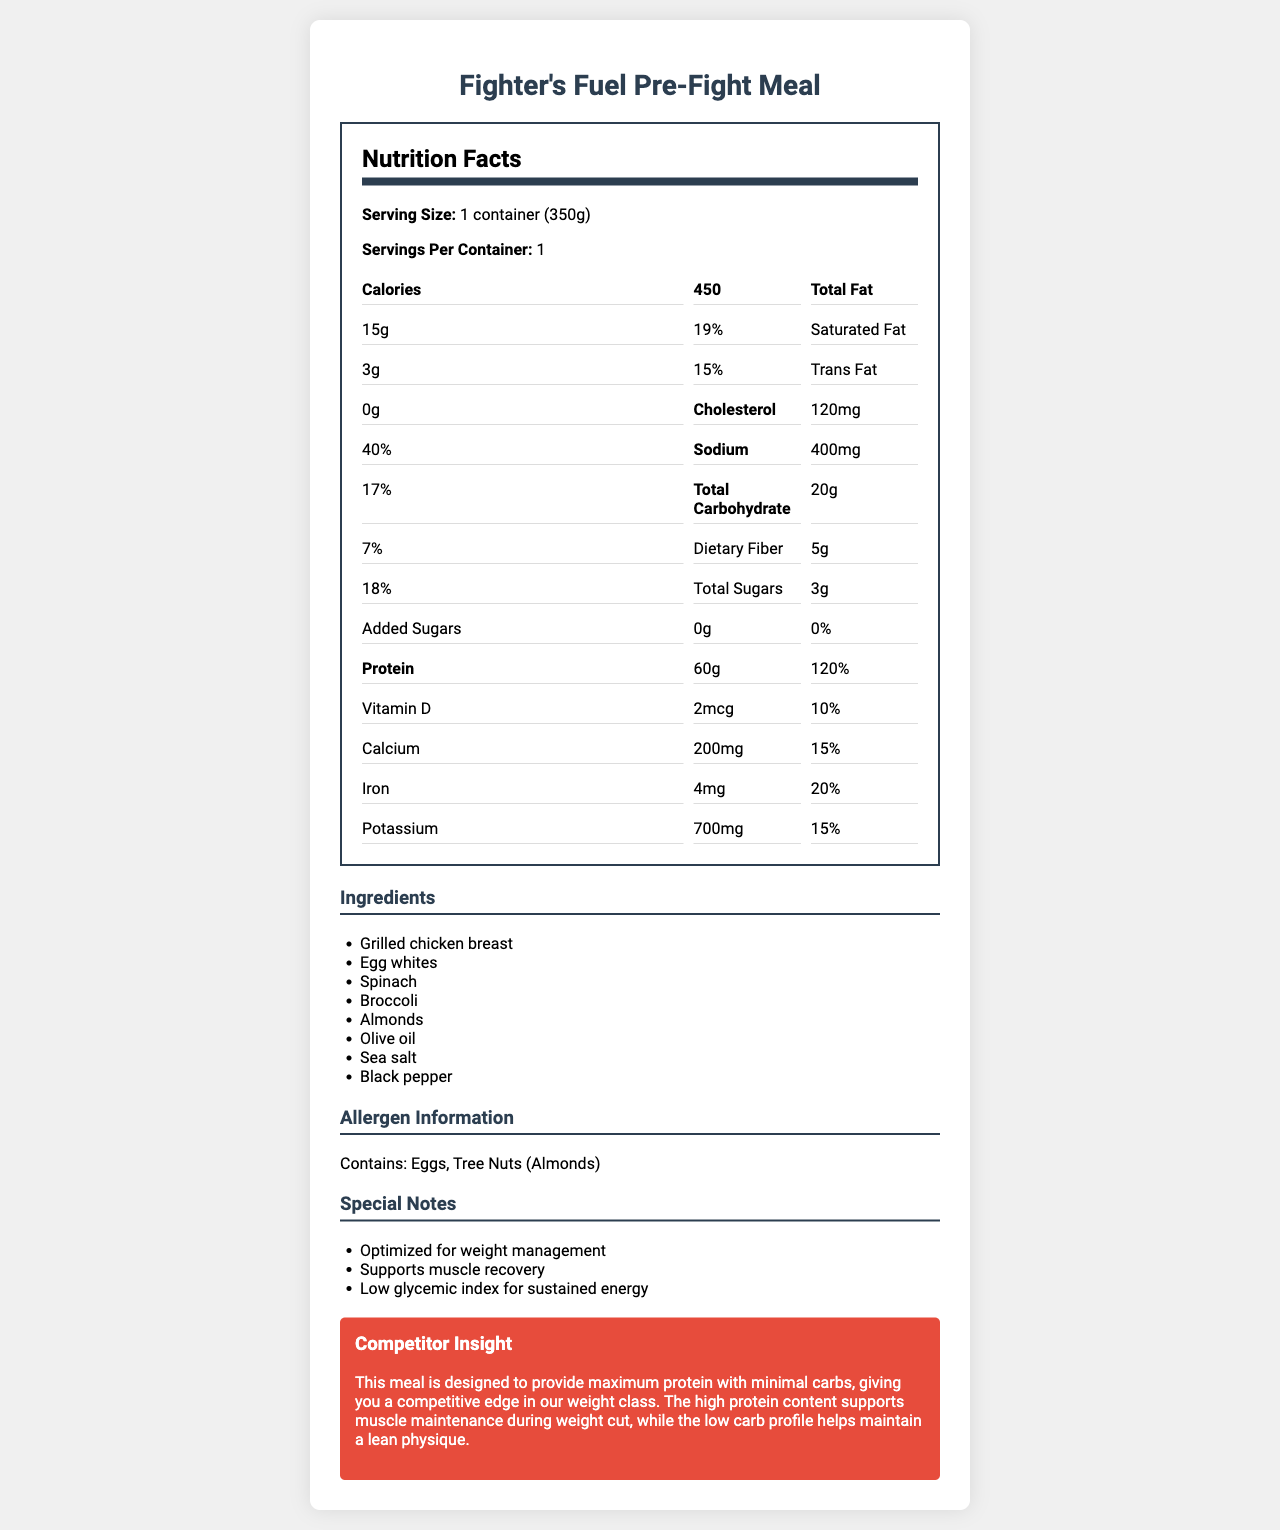what is the serving size of the Fighter's Fuel Pre-Fight Meal? The serving size is stated as "1 container (350g)" in the document.
Answer: 1 container (350g) how many calories are in one serving of the Fighter's Fuel Pre-Fight Meal? The document states that one serving has 450 calories.
Answer: 450 what is the total amount of protein in the Fighter's Fuel Pre-Fight Meal? The document shows that the total protein amount is 60g.
Answer: 60g how much sodium does one serving of Fighter's Fuel Pre-Fight Meal contain? The sodium content per serving is listed as 400mg in the document.
Answer: 400mg which two ingredients in the Fighter's Fuel Pre-Fight Meal are allergens? The allergen information section notes that the meal contains eggs and tree nuts (almonds).
Answer: Eggs, Tree Nuts (Almonds) what is the daily value percentage of calcium in the Fighter's Fuel Pre-Fight Meal? A. 10% B. 15% C. 20% D. 25% The document states that the daily value percentage for calcium is 15%.
Answer: B. 15% which ingredient is not part of the Fighter's Fuel Pre-Fight Meal? I. Grilled chicken breast II. Spinach III. Broccoli IV. Tomatoes The list of ingredients does not include tomatoes.
Answer: IV. Tomatoes is the Fighter's Fuel Pre-Fight Meal considered high in dietary fiber? (yes/no) The meal contains 5g of dietary fiber, which is 18% of the daily value, suggesting it is relatively high in dietary fiber.
Answer: Yes what is the main objective of the Fighter's Fuel Pre-Fight Meal according to the competitor insight? The competitor insight states that the meal is designed to provide maximum protein with minimal carbohydrates.
Answer: Provide maximum protein with minimal carbs how much vitamin D is present in the Fighter's Fuel Pre-Fight Meal? The document lists the vitamin D content as 2mcg.
Answer: 2mcg what are the benefits of the Fighter's Fuel Pre-Fight Meal mentioned in the special notes? These benefits are listed in the special notes section of the document.
Answer: Optimized for weight management, supports muscle recovery, and low glycemic index for sustained energy what is the amount of total carbohydrate in one serving of the Fighter's Fuel Pre-Fight Meal? The total carbohydrate content is 20g per serving.
Answer: 20g is it possible to know the cooking method of the grilled chicken breast from the document? The document lists "Grilled chicken breast" as an ingredient but does not provide details on the cooking method.
Answer: Not enough information summarize the nutritional profile of the Fighter's Fuel Pre-Fight Meal. The document provides comprehensive details on the nutritional content, ingredients, allergen information, and special notes regarding the benefits and design of the meal.
Answer: The Fighter's Fuel Pre-Fight Meal is a high-protein, low-carb meal containing 450 calories per serving. It includes 60g of protein, 15g of total fat, 20g of total carbohydrates, and 5g of dietary fiber. It is designed to optimize weight management, support muscle recovery, and provide sustained energy with a low glycemic index. It contains ingredients such as grilled chicken breast, egg whites, spinach, broccoli, almonds, olive oil, sea salt, and black pepper, and has allergen information noting the presence of eggs and tree nuts. 